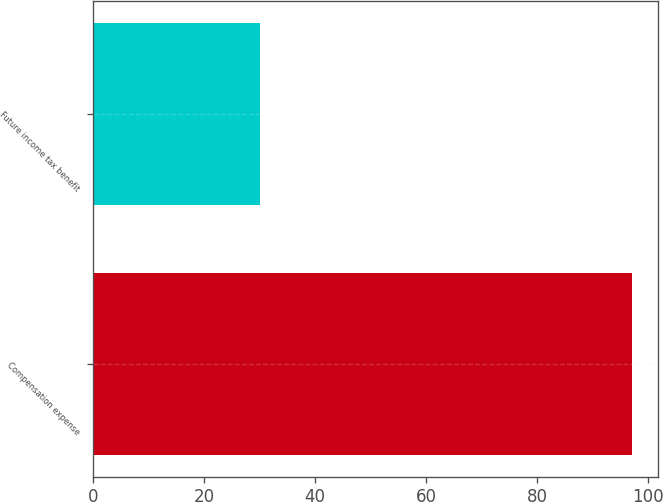<chart> <loc_0><loc_0><loc_500><loc_500><bar_chart><fcel>Compensation expense<fcel>Future income tax benefit<nl><fcel>97<fcel>30<nl></chart> 